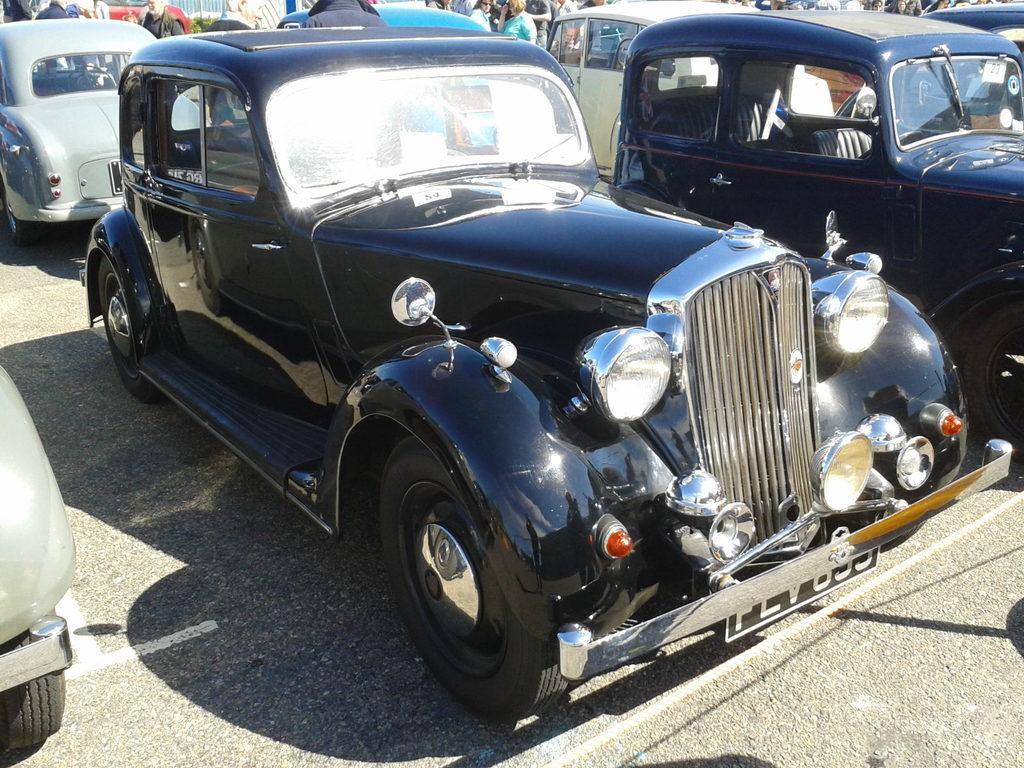What can be seen on the road in the image? There are vehicles on the road in the image. What else is visible in the image besides the vehicles? There is a group of people at the back of the image, a plant, a rope in the foreground, and a road at the bottom of the image. What type of stretch is the group of people doing in the image? There is no indication in the image that the group of people is doing any stretches; they are simply standing or walking. 